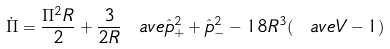Convert formula to latex. <formula><loc_0><loc_0><loc_500><loc_500>\dot { \Pi } = \frac { \Pi ^ { 2 } R } { 2 } + \frac { 3 } { 2 { R } } \ a v e { \hat { p } ^ { 2 } _ { + } + \hat { p } ^ { 2 } _ { - } } - 1 8 R ^ { 3 } ( \ a v e { V } - 1 )</formula> 